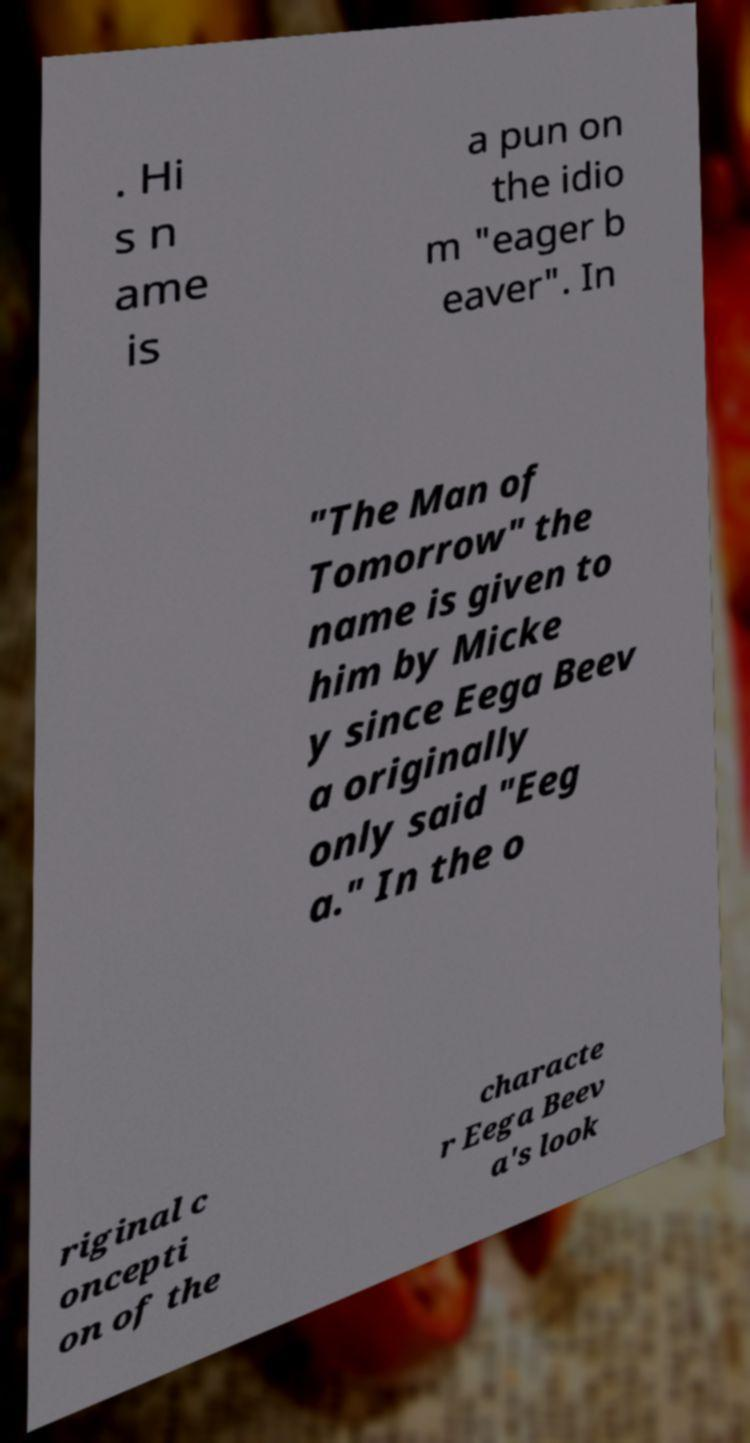Can you read and provide the text displayed in the image?This photo seems to have some interesting text. Can you extract and type it out for me? . Hi s n ame is a pun on the idio m "eager b eaver". In "The Man of Tomorrow" the name is given to him by Micke y since Eega Beev a originally only said "Eeg a." In the o riginal c oncepti on of the characte r Eega Beev a's look 